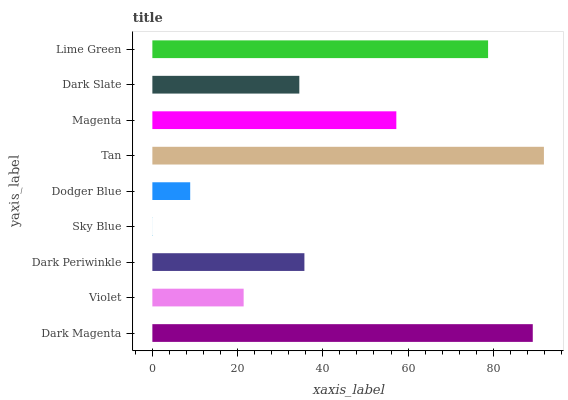Is Sky Blue the minimum?
Answer yes or no. Yes. Is Tan the maximum?
Answer yes or no. Yes. Is Violet the minimum?
Answer yes or no. No. Is Violet the maximum?
Answer yes or no. No. Is Dark Magenta greater than Violet?
Answer yes or no. Yes. Is Violet less than Dark Magenta?
Answer yes or no. Yes. Is Violet greater than Dark Magenta?
Answer yes or no. No. Is Dark Magenta less than Violet?
Answer yes or no. No. Is Dark Periwinkle the high median?
Answer yes or no. Yes. Is Dark Periwinkle the low median?
Answer yes or no. Yes. Is Magenta the high median?
Answer yes or no. No. Is Dark Slate the low median?
Answer yes or no. No. 